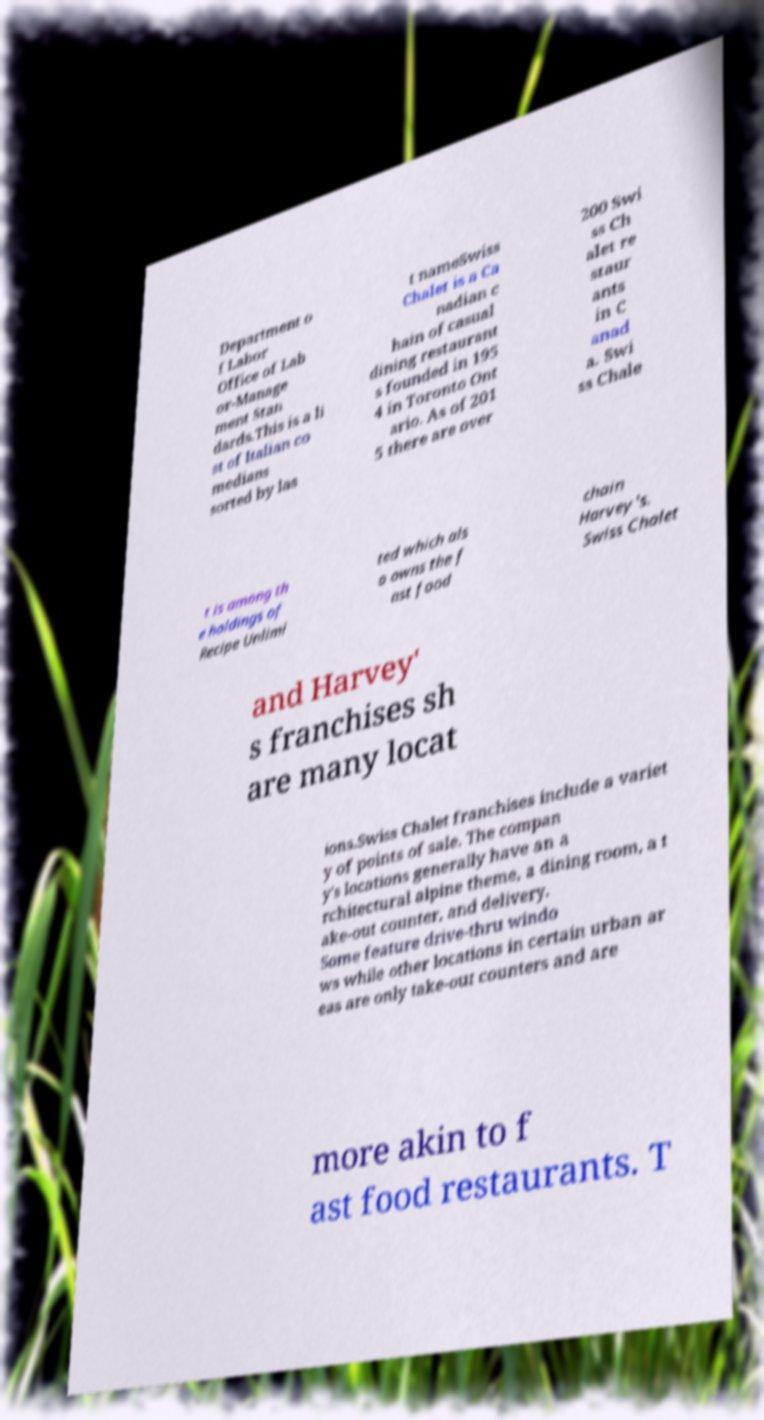Could you extract and type out the text from this image? Department o f Labor Office of Lab or-Manage ment Stan dards.This is a li st of Italian co medians sorted by las t nameSwiss Chalet is a Ca nadian c hain of casual dining restaurant s founded in 195 4 in Toronto Ont ario. As of 201 5 there are over 200 Swi ss Ch alet re staur ants in C anad a. Swi ss Chale t is among th e holdings of Recipe Unlimi ted which als o owns the f ast food chain Harvey's. Swiss Chalet and Harvey' s franchises sh are many locat ions.Swiss Chalet franchises include a variet y of points of sale. The compan y's locations generally have an a rchitectural alpine theme, a dining room, a t ake-out counter, and delivery. Some feature drive-thru windo ws while other locations in certain urban ar eas are only take-out counters and are more akin to f ast food restaurants. T 